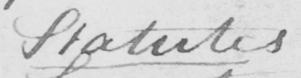Please transcribe the handwritten text in this image. Statutes 